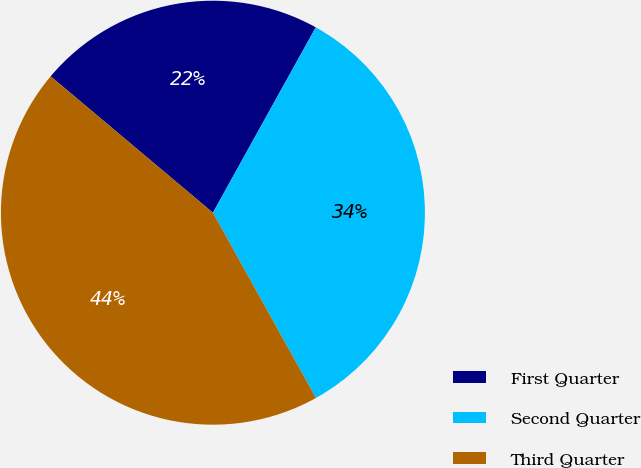Convert chart. <chart><loc_0><loc_0><loc_500><loc_500><pie_chart><fcel>First Quarter<fcel>Second Quarter<fcel>Third Quarter<nl><fcel>21.94%<fcel>33.86%<fcel>44.2%<nl></chart> 